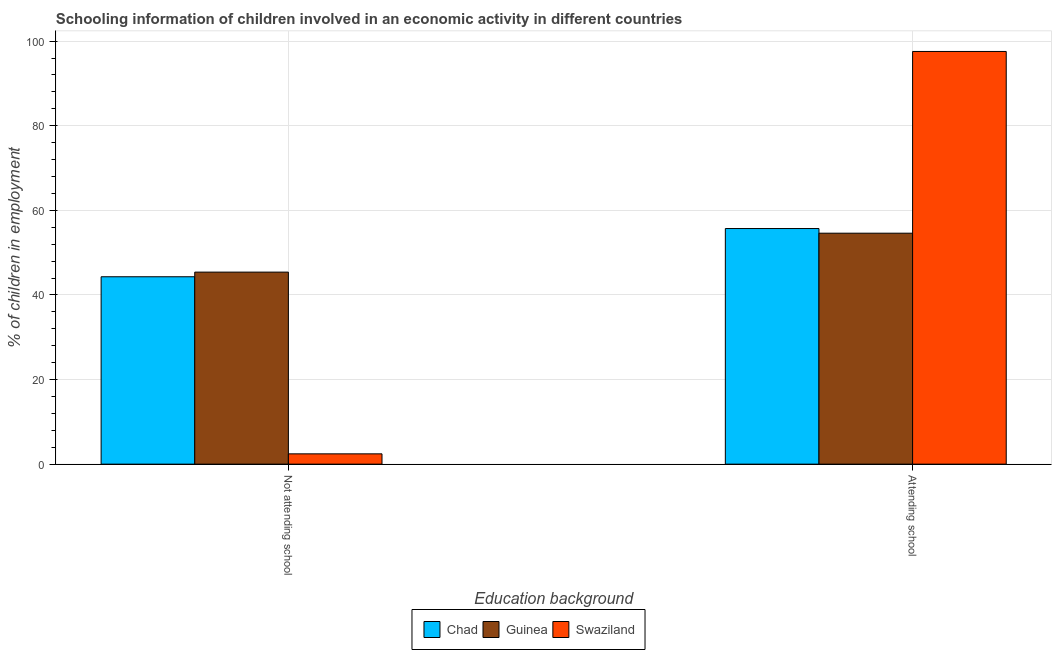Are the number of bars per tick equal to the number of legend labels?
Your answer should be very brief. Yes. How many bars are there on the 2nd tick from the left?
Keep it short and to the point. 3. What is the label of the 2nd group of bars from the left?
Offer a very short reply. Attending school. What is the percentage of employed children who are not attending school in Swaziland?
Provide a short and direct response. 2.44. Across all countries, what is the maximum percentage of employed children who are attending school?
Provide a succinct answer. 97.56. Across all countries, what is the minimum percentage of employed children who are not attending school?
Your answer should be very brief. 2.44. In which country was the percentage of employed children who are attending school maximum?
Make the answer very short. Swaziland. In which country was the percentage of employed children who are not attending school minimum?
Offer a very short reply. Swaziland. What is the total percentage of employed children who are attending school in the graph?
Ensure brevity in your answer.  207.86. What is the difference between the percentage of employed children who are attending school in Swaziland and that in Guinea?
Offer a very short reply. 42.96. What is the difference between the percentage of employed children who are attending school in Swaziland and the percentage of employed children who are not attending school in Guinea?
Your response must be concise. 52.16. What is the average percentage of employed children who are attending school per country?
Your answer should be compact. 69.29. What is the difference between the percentage of employed children who are attending school and percentage of employed children who are not attending school in Guinea?
Make the answer very short. 9.2. In how many countries, is the percentage of employed children who are attending school greater than 84 %?
Provide a succinct answer. 1. What is the ratio of the percentage of employed children who are attending school in Swaziland to that in Chad?
Offer a very short reply. 1.75. What does the 2nd bar from the left in Not attending school represents?
Keep it short and to the point. Guinea. What does the 3rd bar from the right in Attending school represents?
Give a very brief answer. Chad. How many bars are there?
Provide a succinct answer. 6. Are all the bars in the graph horizontal?
Give a very brief answer. No. What is the difference between two consecutive major ticks on the Y-axis?
Make the answer very short. 20. Are the values on the major ticks of Y-axis written in scientific E-notation?
Provide a succinct answer. No. Does the graph contain any zero values?
Make the answer very short. No. What is the title of the graph?
Your answer should be compact. Schooling information of children involved in an economic activity in different countries. Does "Georgia" appear as one of the legend labels in the graph?
Provide a succinct answer. No. What is the label or title of the X-axis?
Offer a terse response. Education background. What is the label or title of the Y-axis?
Offer a terse response. % of children in employment. What is the % of children in employment of Chad in Not attending school?
Your response must be concise. 44.3. What is the % of children in employment in Guinea in Not attending school?
Offer a very short reply. 45.4. What is the % of children in employment of Swaziland in Not attending school?
Offer a very short reply. 2.44. What is the % of children in employment of Chad in Attending school?
Your response must be concise. 55.7. What is the % of children in employment in Guinea in Attending school?
Give a very brief answer. 54.6. What is the % of children in employment of Swaziland in Attending school?
Keep it short and to the point. 97.56. Across all Education background, what is the maximum % of children in employment in Chad?
Your answer should be very brief. 55.7. Across all Education background, what is the maximum % of children in employment in Guinea?
Offer a terse response. 54.6. Across all Education background, what is the maximum % of children in employment in Swaziland?
Offer a very short reply. 97.56. Across all Education background, what is the minimum % of children in employment of Chad?
Provide a short and direct response. 44.3. Across all Education background, what is the minimum % of children in employment of Guinea?
Provide a short and direct response. 45.4. Across all Education background, what is the minimum % of children in employment of Swaziland?
Make the answer very short. 2.44. What is the total % of children in employment in Chad in the graph?
Your response must be concise. 100. What is the total % of children in employment in Guinea in the graph?
Your answer should be very brief. 100. What is the total % of children in employment in Swaziland in the graph?
Your response must be concise. 100. What is the difference between the % of children in employment of Swaziland in Not attending school and that in Attending school?
Keep it short and to the point. -95.13. What is the difference between the % of children in employment of Chad in Not attending school and the % of children in employment of Guinea in Attending school?
Offer a very short reply. -10.3. What is the difference between the % of children in employment in Chad in Not attending school and the % of children in employment in Swaziland in Attending school?
Give a very brief answer. -53.26. What is the difference between the % of children in employment of Guinea in Not attending school and the % of children in employment of Swaziland in Attending school?
Provide a short and direct response. -52.16. What is the average % of children in employment of Chad per Education background?
Provide a short and direct response. 50. What is the average % of children in employment of Guinea per Education background?
Give a very brief answer. 50. What is the average % of children in employment of Swaziland per Education background?
Offer a very short reply. 50. What is the difference between the % of children in employment in Chad and % of children in employment in Guinea in Not attending school?
Your response must be concise. -1.1. What is the difference between the % of children in employment in Chad and % of children in employment in Swaziland in Not attending school?
Offer a very short reply. 41.86. What is the difference between the % of children in employment of Guinea and % of children in employment of Swaziland in Not attending school?
Ensure brevity in your answer.  42.96. What is the difference between the % of children in employment of Chad and % of children in employment of Swaziland in Attending school?
Your answer should be compact. -41.86. What is the difference between the % of children in employment of Guinea and % of children in employment of Swaziland in Attending school?
Your answer should be very brief. -42.96. What is the ratio of the % of children in employment of Chad in Not attending school to that in Attending school?
Keep it short and to the point. 0.8. What is the ratio of the % of children in employment in Guinea in Not attending school to that in Attending school?
Ensure brevity in your answer.  0.83. What is the ratio of the % of children in employment of Swaziland in Not attending school to that in Attending school?
Your answer should be very brief. 0.03. What is the difference between the highest and the second highest % of children in employment of Chad?
Offer a very short reply. 11.4. What is the difference between the highest and the second highest % of children in employment in Guinea?
Keep it short and to the point. 9.2. What is the difference between the highest and the second highest % of children in employment of Swaziland?
Your answer should be very brief. 95.13. What is the difference between the highest and the lowest % of children in employment in Chad?
Your answer should be very brief. 11.4. What is the difference between the highest and the lowest % of children in employment of Guinea?
Make the answer very short. 9.2. What is the difference between the highest and the lowest % of children in employment of Swaziland?
Your response must be concise. 95.13. 